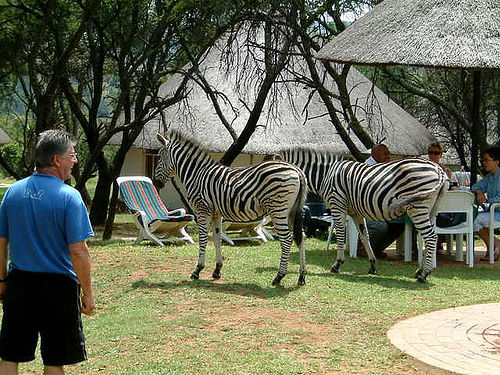How many zebras can be seen? In the image, there are two zebras visible. They're mingling casually among the people, who seem to be enjoying a leisurely time outdoors, possibly at a retreat or a park where wildlife roams freely. 